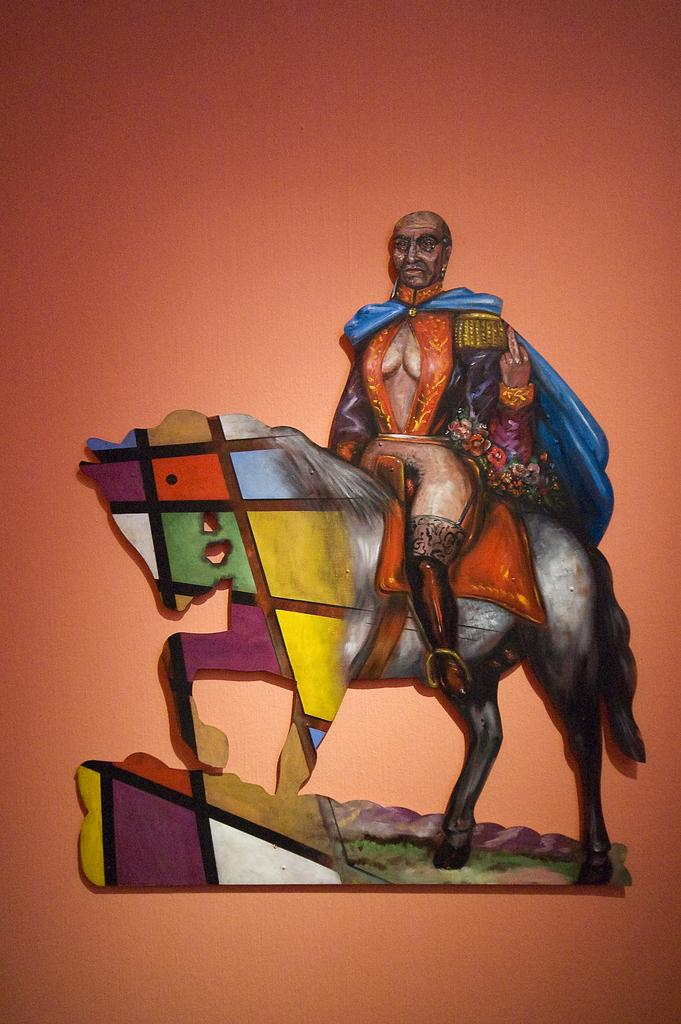What is the main object in the image? There is a board in the image. What is depicted on the board? The board features a person sitting on a horse. Where is the board located? The board is on a surface. Can you see any grass growing on the board in the image? There is no grass present on the board in the image. How many people are pulling the horse in the image? There are no people pulling the horse in the image; the person is sitting on the horse. 